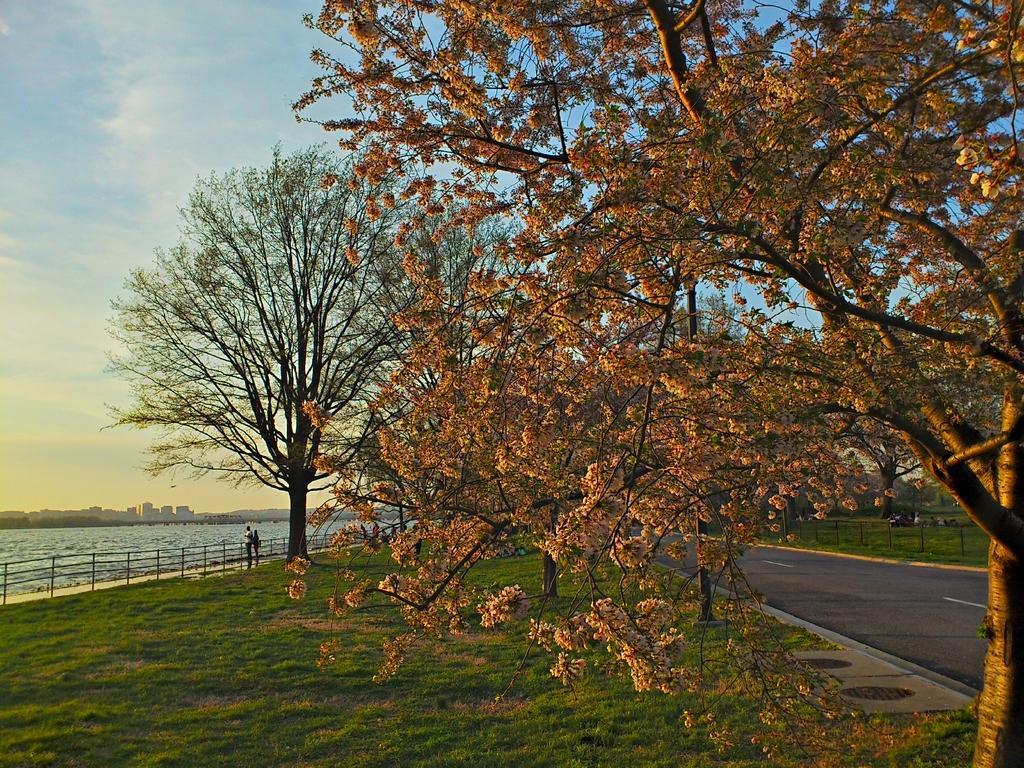Please provide a concise description of this image. In this image I can see few trees, water, fencing, few buildings and the sky. I can see few people are standing. 